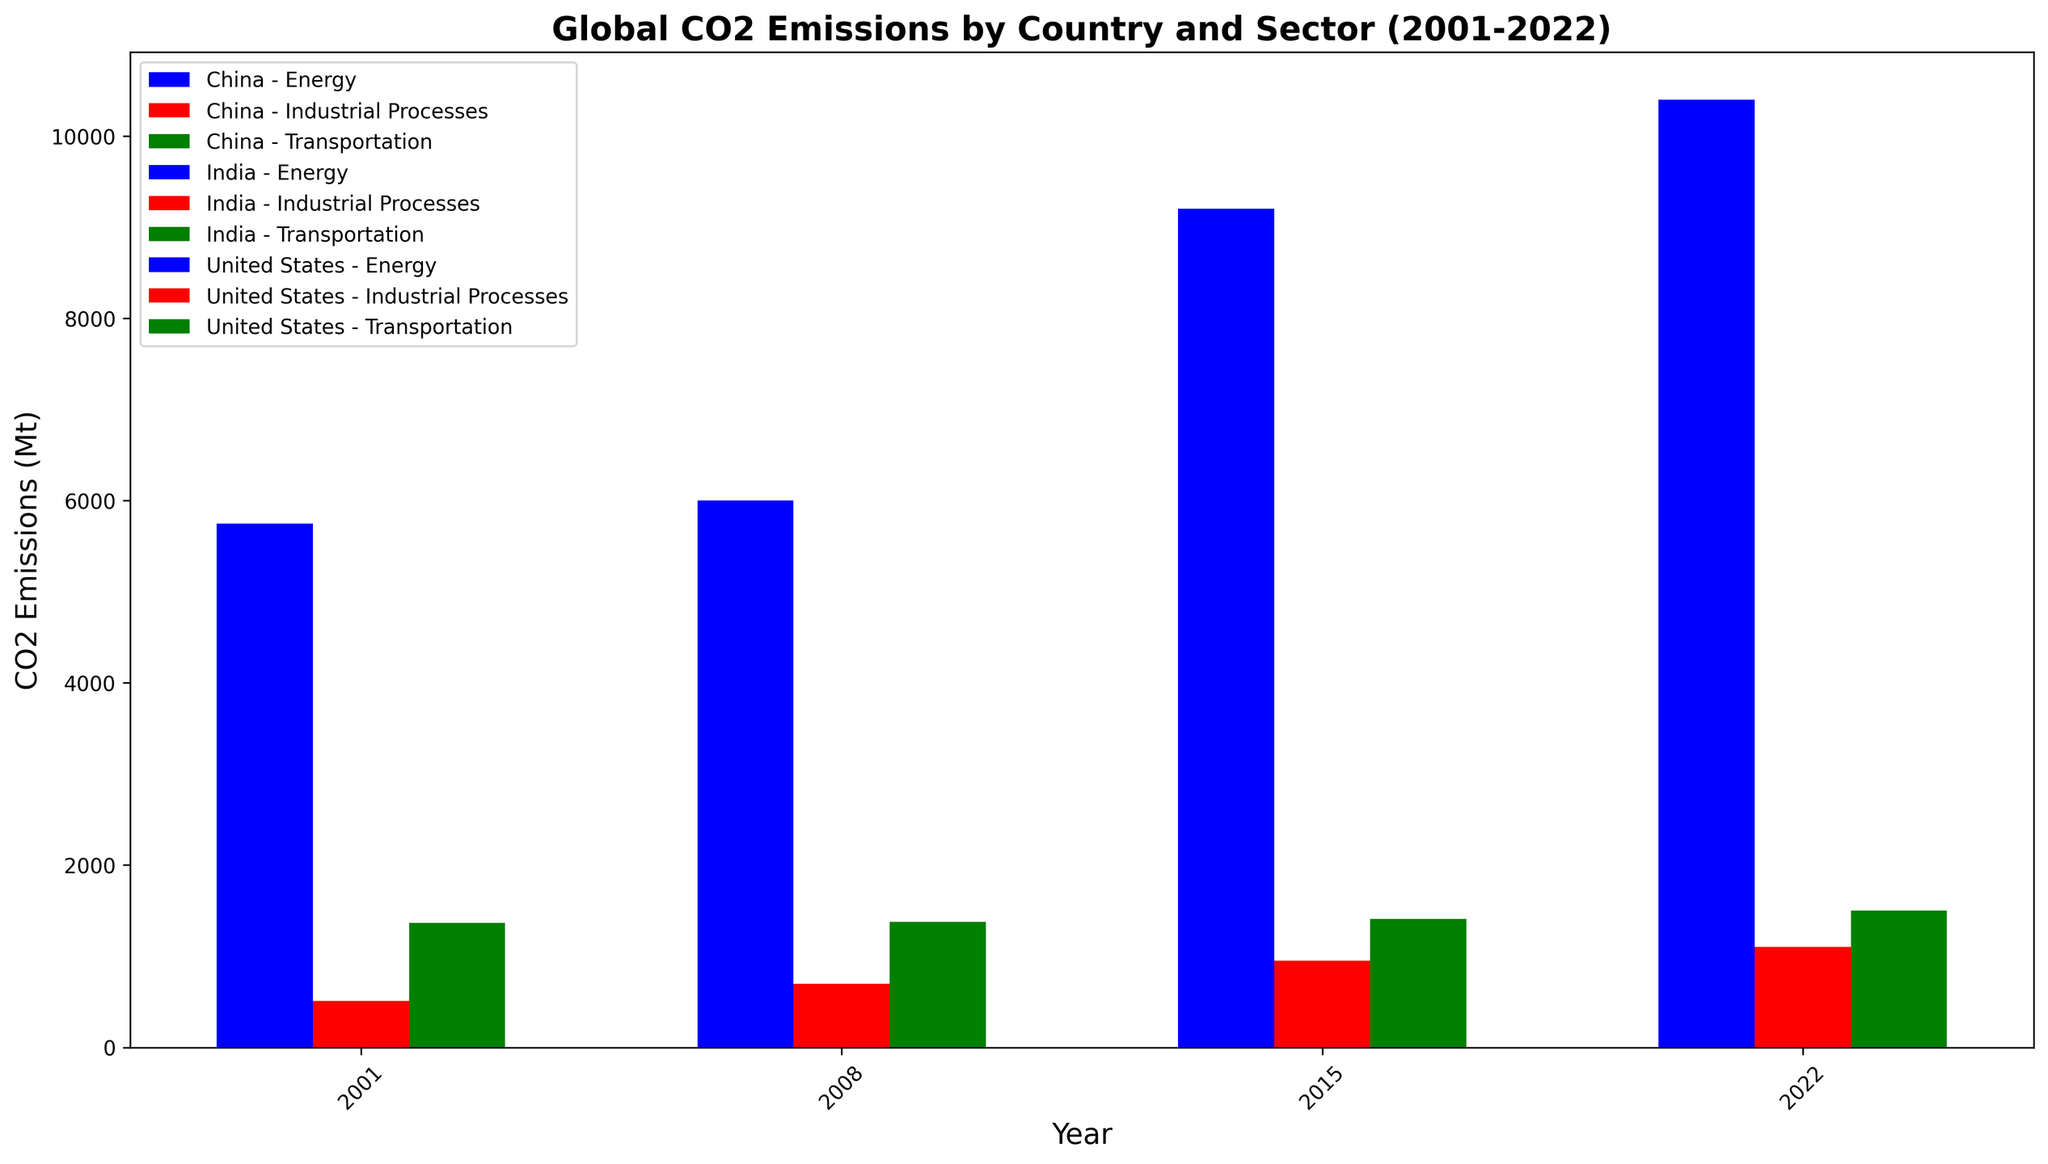Which country had the highest CO2 emissions from the energy sector in 2022? The bar representing China's energy sector for 2022 is the tallest among all countries and sectors shown.
Answer: China By how much did China's CO2 emissions from industrial processes increase between 2001 and 2022? The CO2 emissions from industrial processes in China in 2001 were 400 Mt and in 2022 were 1100 Mt. The increase is 1100 - 400 = 700 Mt.
Answer: 700 Mt For the United States, which sector saw the least fluctuation in CO2 emissions from 2001 to 2022? Comparing the heights of the bars for each sector of the United States over the years, the industrial processes sector shows the least change.
Answer: Industrial Processes In 2015, which country's transportation sector had higher CO2 emissions, the United States or China? The height of the bar for the transportation sector of the United States in 2015 (1410 Mt) is higher than that of China (750 Mt).
Answer: United States Which year shows the largest contribution from India's industrial processes to its total CO2 emissions from all sectors combined? Adding the heights for India's industrial processes in each year: 
2001: 150 Mt,
2008: 250 Mt,
2015: 300 Mt,
2022: 350 Mt.
The maximum is in 2022.
Answer: 2022 Did India's CO2 emissions from the energy sector ever surpass the United States' emissions from the industrial processes sector? India's energy sector emissions in 2001 were 1100 Mt, in 2008 were 1500 Mt, in 2015 were 2000 Mt, and in 2022 were 2300 Mt. The United States' industrial processes emissions were always below 600 Mt in those years.
Answer: Yes What is the average CO2 emission from transportation for China over the years shown? The transportation CO2 emissions for China are:
2001: 250 Mt,
2008: 500 Mt,
2015: 750 Mt,
2022: 850 Mt.
The average is (250 + 500 + 750 + 850) / 4 = 587.5 Mt.
Answer: 587.5 Mt Which country showed the greatest increase in CO2 emissions from the energy sector from 2001 to 2022? The CO2 emissions from the energy sector in China increased from 3164 Mt in 2001 to 10400 Mt in 2022, a difference of 7236 Mt, which is the greatest among countries shown.
Answer: China In 2008, how do the combined CO2 emissions from all sectors in India compare to just the energy sector emissions of China in the same year? Summing India's emissions in 2008 gives:
Energy: 1500 Mt,
Transportation: 350 Mt,
Industrial Processes: 250 Mt.
Total = 1500 + 350 + 250 = 2100 Mt. 
China's energy sector alone was 6000 Mt. Therefore, India's total is less than China's energy emissions alone.
Answer: Less From 2001 to 2022, which sector in China had the highest absolute growth in CO2 emissions? The growth for each sector in China:
Energy: 10400 Mt - 3164 Mt = 7236 Mt,
Transportation: 850 Mt - 250 Mt = 600 Mt,
Industrial Processes: 1100 Mt - 400 Mt = 700 Mt.
The energy sector had the highest absolute growth.
Answer: Energy 